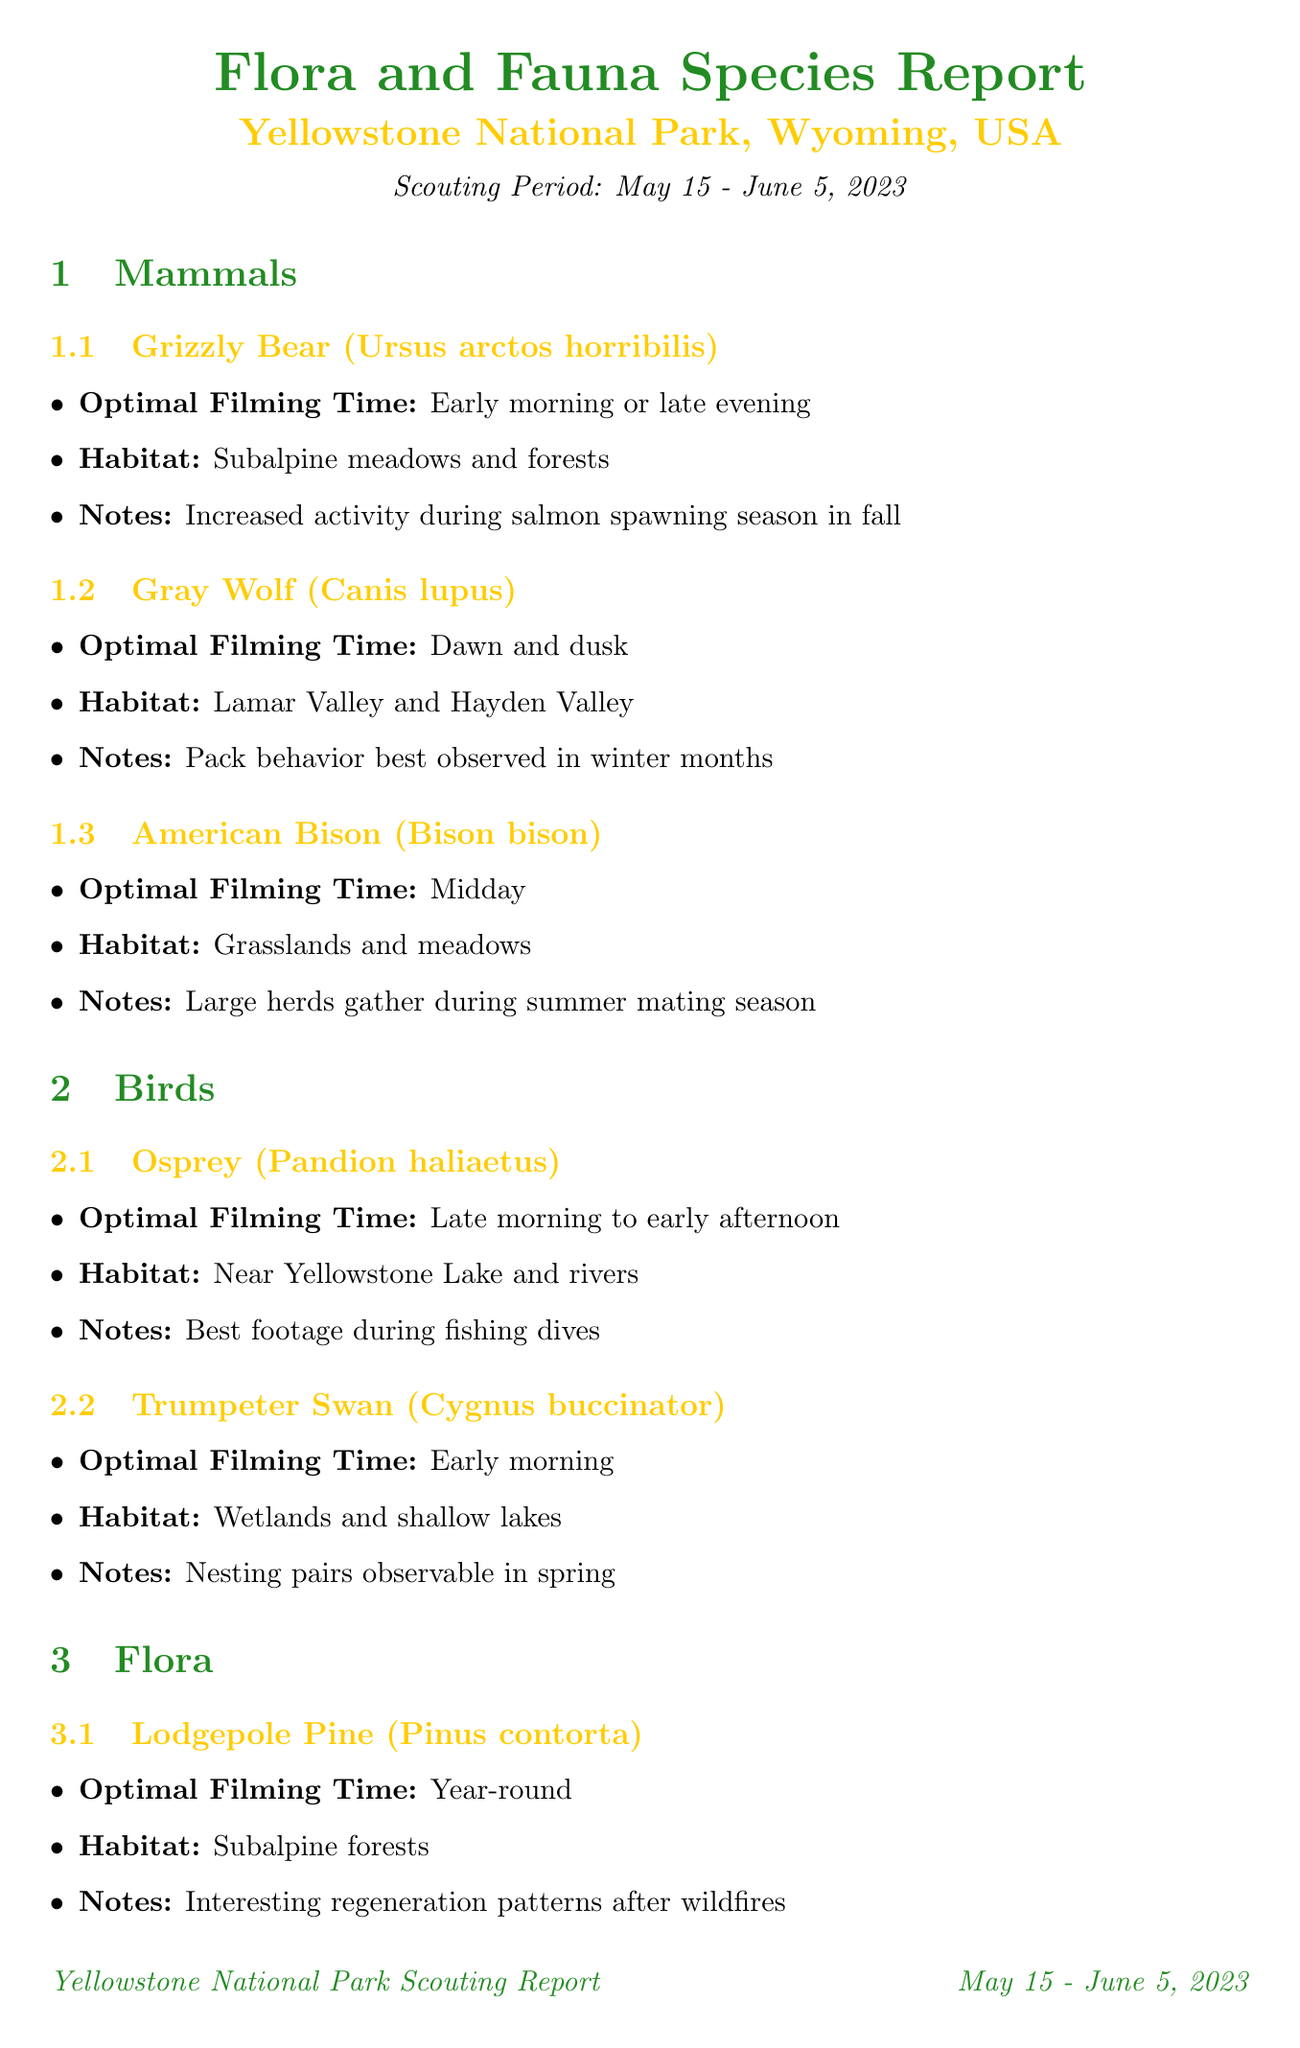what is the location of the study? The location of the study is specified in the document as Yellowstone National Park, Wyoming, USA.
Answer: Yellowstone National Park, Wyoming, USA what is the optimal filming time for Grizzly Bears? The optimal filming time for Grizzly Bears is mentioned in the document as early morning or late evening.
Answer: Early morning or late evening which geological feature is best filmed during midday? The document states that the Grand Prismatic Spring is best filmed during midday for the best colors.
Answer: Grand Prismatic Spring how many mammals species are listed in the report? The report lists three mammal species: Grizzly Bear, Gray Wolf, and American Bison.
Answer: Three what is the habitat of the Osprey? The habitat of the Osprey is described as near Yellowstone Lake and rivers in the document.
Answer: Near Yellowstone Lake and rivers who is the contact for the Yellowstone Wolf Project? The document provides Dr. Emily Hawkins as the contact for the Yellowstone Wolf Project.
Answer: Dr. Emily Hawkins what is recommended to reduce glare on water surfaces? The document recommends using a polarizing filter to reduce glare on water surfaces and enhance colors.
Answer: Polarizing filter what should be carried for safety against bears? According to the safety considerations in the document, bear spray should be carried for safety against bears.
Answer: Bear spray 